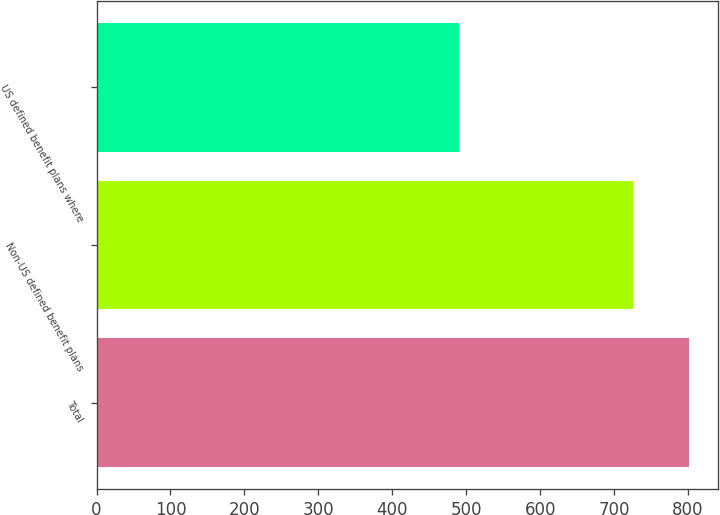<chart> <loc_0><loc_0><loc_500><loc_500><bar_chart><fcel>Total<fcel>Non-US defined benefit plans<fcel>US defined benefit plans where<nl><fcel>800.6<fcel>724.8<fcel>490<nl></chart> 